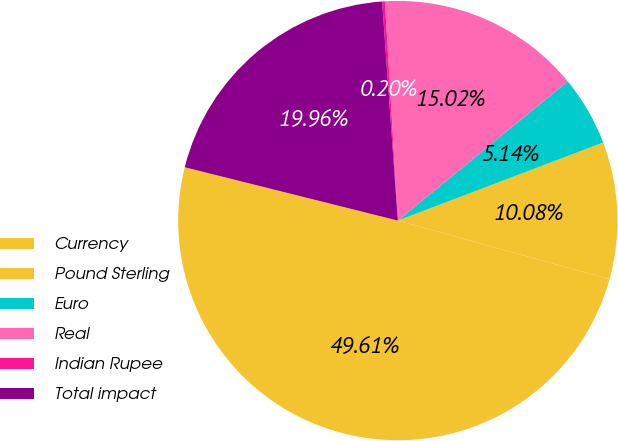Convert chart. <chart><loc_0><loc_0><loc_500><loc_500><pie_chart><fcel>Currency<fcel>Pound Sterling<fcel>Euro<fcel>Real<fcel>Indian Rupee<fcel>Total impact<nl><fcel>49.61%<fcel>10.08%<fcel>5.14%<fcel>15.02%<fcel>0.2%<fcel>19.96%<nl></chart> 